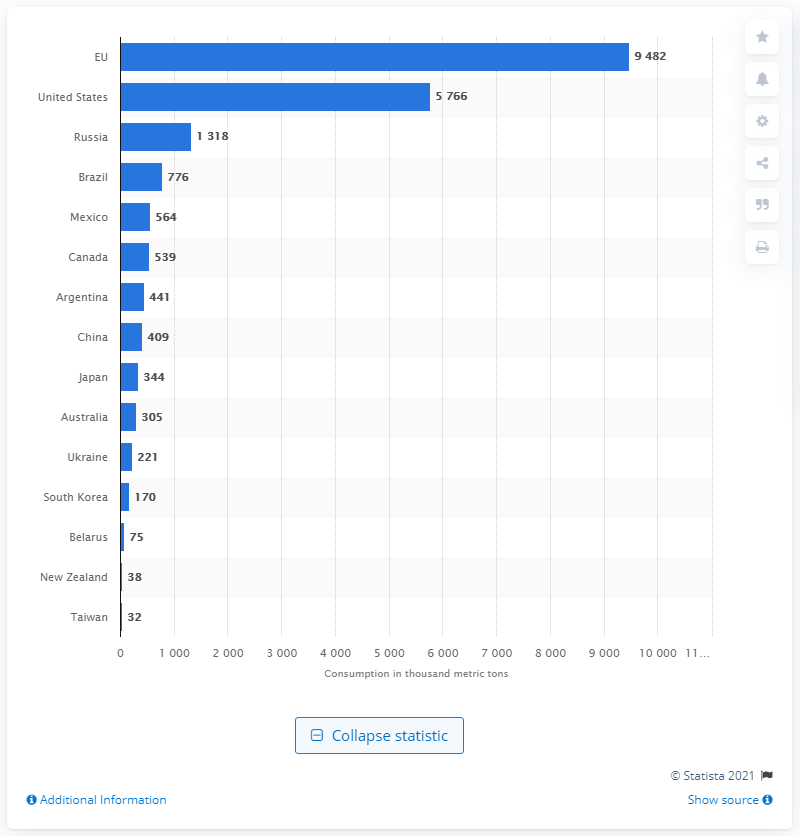Highlight a few significant elements in this photo. The country with a population three times larger than the European Union is China. 